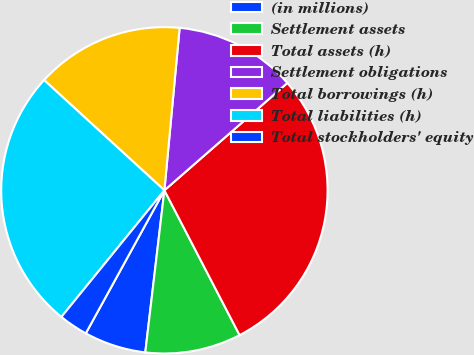Convert chart. <chart><loc_0><loc_0><loc_500><loc_500><pie_chart><fcel>(in millions)<fcel>Settlement assets<fcel>Total assets (h)<fcel>Settlement obligations<fcel>Total borrowings (h)<fcel>Total liabilities (h)<fcel>Total stockholders' equity<nl><fcel>6.13%<fcel>9.49%<fcel>28.8%<fcel>12.09%<fcel>14.68%<fcel>25.94%<fcel>2.87%<nl></chart> 